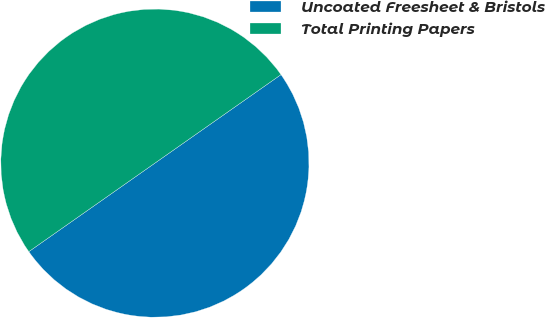Convert chart to OTSL. <chart><loc_0><loc_0><loc_500><loc_500><pie_chart><fcel>Uncoated Freesheet & Bristols<fcel>Total Printing Papers<nl><fcel>50.0%<fcel>50.0%<nl></chart> 